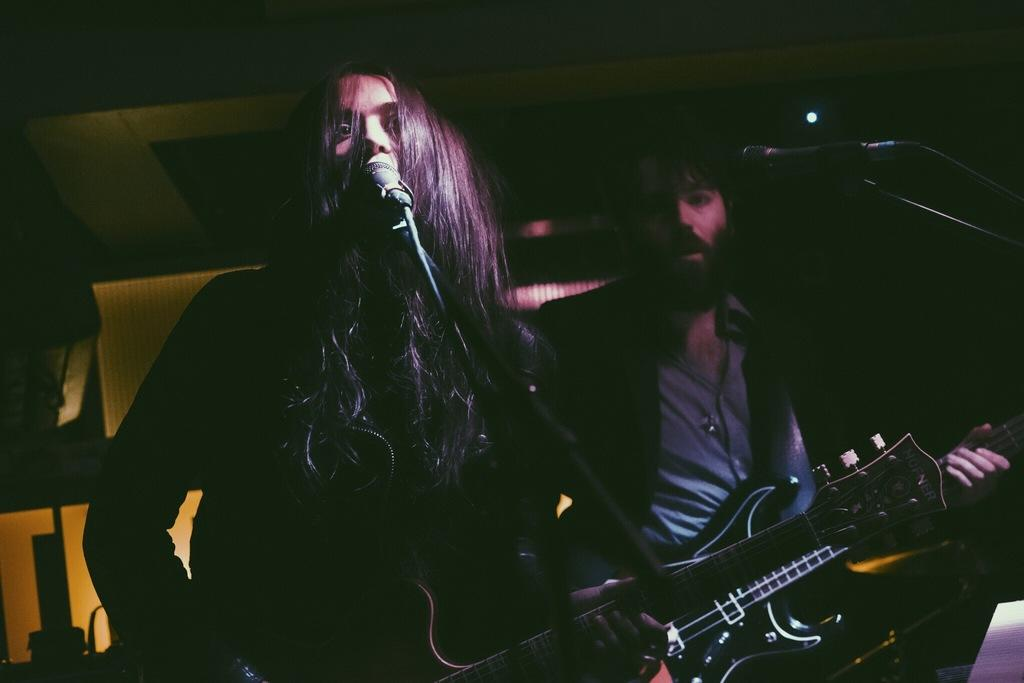How many people are in the image? There are two people in the image. What are the two people doing in the image? The two people are standing and holding guitars. What objects are present in front of the two people? There are microphones present in front of the two people. What type of insect is crawling on the guitar of the person on the left? There is no insect present on the guitar of the person on the left; only the guitar and the person holding it are visible. 